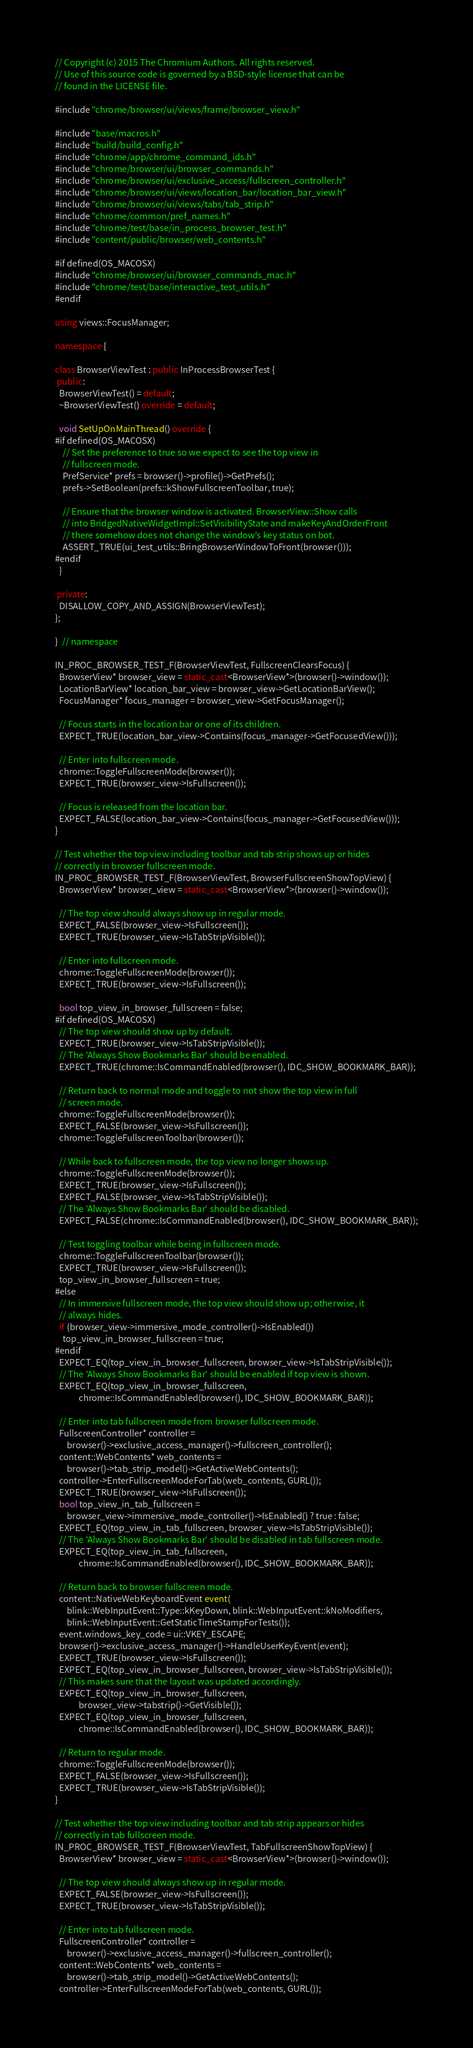Convert code to text. <code><loc_0><loc_0><loc_500><loc_500><_C++_>// Copyright (c) 2015 The Chromium Authors. All rights reserved.
// Use of this source code is governed by a BSD-style license that can be
// found in the LICENSE file.

#include "chrome/browser/ui/views/frame/browser_view.h"

#include "base/macros.h"
#include "build/build_config.h"
#include "chrome/app/chrome_command_ids.h"
#include "chrome/browser/ui/browser_commands.h"
#include "chrome/browser/ui/exclusive_access/fullscreen_controller.h"
#include "chrome/browser/ui/views/location_bar/location_bar_view.h"
#include "chrome/browser/ui/views/tabs/tab_strip.h"
#include "chrome/common/pref_names.h"
#include "chrome/test/base/in_process_browser_test.h"
#include "content/public/browser/web_contents.h"

#if defined(OS_MACOSX)
#include "chrome/browser/ui/browser_commands_mac.h"
#include "chrome/test/base/interactive_test_utils.h"
#endif

using views::FocusManager;

namespace {

class BrowserViewTest : public InProcessBrowserTest {
 public:
  BrowserViewTest() = default;
  ~BrowserViewTest() override = default;

  void SetUpOnMainThread() override {
#if defined(OS_MACOSX)
    // Set the preference to true so we expect to see the top view in
    // fullscreen mode.
    PrefService* prefs = browser()->profile()->GetPrefs();
    prefs->SetBoolean(prefs::kShowFullscreenToolbar, true);

    // Ensure that the browser window is activated. BrowserView::Show calls
    // into BridgedNativeWidgetImpl::SetVisibilityState and makeKeyAndOrderFront
    // there somehow does not change the window's key status on bot.
    ASSERT_TRUE(ui_test_utils::BringBrowserWindowToFront(browser()));
#endif
  }

 private:
  DISALLOW_COPY_AND_ASSIGN(BrowserViewTest);
};

}  // namespace

IN_PROC_BROWSER_TEST_F(BrowserViewTest, FullscreenClearsFocus) {
  BrowserView* browser_view = static_cast<BrowserView*>(browser()->window());
  LocationBarView* location_bar_view = browser_view->GetLocationBarView();
  FocusManager* focus_manager = browser_view->GetFocusManager();

  // Focus starts in the location bar or one of its children.
  EXPECT_TRUE(location_bar_view->Contains(focus_manager->GetFocusedView()));

  // Enter into fullscreen mode.
  chrome::ToggleFullscreenMode(browser());
  EXPECT_TRUE(browser_view->IsFullscreen());

  // Focus is released from the location bar.
  EXPECT_FALSE(location_bar_view->Contains(focus_manager->GetFocusedView()));
}

// Test whether the top view including toolbar and tab strip shows up or hides
// correctly in browser fullscreen mode.
IN_PROC_BROWSER_TEST_F(BrowserViewTest, BrowserFullscreenShowTopView) {
  BrowserView* browser_view = static_cast<BrowserView*>(browser()->window());

  // The top view should always show up in regular mode.
  EXPECT_FALSE(browser_view->IsFullscreen());
  EXPECT_TRUE(browser_view->IsTabStripVisible());

  // Enter into fullscreen mode.
  chrome::ToggleFullscreenMode(browser());
  EXPECT_TRUE(browser_view->IsFullscreen());

  bool top_view_in_browser_fullscreen = false;
#if defined(OS_MACOSX)
  // The top view should show up by default.
  EXPECT_TRUE(browser_view->IsTabStripVisible());
  // The 'Always Show Bookmarks Bar' should be enabled.
  EXPECT_TRUE(chrome::IsCommandEnabled(browser(), IDC_SHOW_BOOKMARK_BAR));

  // Return back to normal mode and toggle to not show the top view in full
  // screen mode.
  chrome::ToggleFullscreenMode(browser());
  EXPECT_FALSE(browser_view->IsFullscreen());
  chrome::ToggleFullscreenToolbar(browser());

  // While back to fullscreen mode, the top view no longer shows up.
  chrome::ToggleFullscreenMode(browser());
  EXPECT_TRUE(browser_view->IsFullscreen());
  EXPECT_FALSE(browser_view->IsTabStripVisible());
  // The 'Always Show Bookmarks Bar' should be disabled.
  EXPECT_FALSE(chrome::IsCommandEnabled(browser(), IDC_SHOW_BOOKMARK_BAR));

  // Test toggling toolbar while being in fullscreen mode.
  chrome::ToggleFullscreenToolbar(browser());
  EXPECT_TRUE(browser_view->IsFullscreen());
  top_view_in_browser_fullscreen = true;
#else
  // In immersive fullscreen mode, the top view should show up; otherwise, it
  // always hides.
  if (browser_view->immersive_mode_controller()->IsEnabled())
    top_view_in_browser_fullscreen = true;
#endif
  EXPECT_EQ(top_view_in_browser_fullscreen, browser_view->IsTabStripVisible());
  // The 'Always Show Bookmarks Bar' should be enabled if top view is shown.
  EXPECT_EQ(top_view_in_browser_fullscreen,
            chrome::IsCommandEnabled(browser(), IDC_SHOW_BOOKMARK_BAR));

  // Enter into tab fullscreen mode from browser fullscreen mode.
  FullscreenController* controller =
      browser()->exclusive_access_manager()->fullscreen_controller();
  content::WebContents* web_contents =
      browser()->tab_strip_model()->GetActiveWebContents();
  controller->EnterFullscreenModeForTab(web_contents, GURL());
  EXPECT_TRUE(browser_view->IsFullscreen());
  bool top_view_in_tab_fullscreen =
      browser_view->immersive_mode_controller()->IsEnabled() ? true : false;
  EXPECT_EQ(top_view_in_tab_fullscreen, browser_view->IsTabStripVisible());
  // The 'Always Show Bookmarks Bar' should be disabled in tab fullscreen mode.
  EXPECT_EQ(top_view_in_tab_fullscreen,
            chrome::IsCommandEnabled(browser(), IDC_SHOW_BOOKMARK_BAR));

  // Return back to browser fullscreen mode.
  content::NativeWebKeyboardEvent event(
      blink::WebInputEvent::Type::kKeyDown, blink::WebInputEvent::kNoModifiers,
      blink::WebInputEvent::GetStaticTimeStampForTests());
  event.windows_key_code = ui::VKEY_ESCAPE;
  browser()->exclusive_access_manager()->HandleUserKeyEvent(event);
  EXPECT_TRUE(browser_view->IsFullscreen());
  EXPECT_EQ(top_view_in_browser_fullscreen, browser_view->IsTabStripVisible());
  // This makes sure that the layout was updated accordingly.
  EXPECT_EQ(top_view_in_browser_fullscreen,
            browser_view->tabstrip()->GetVisible());
  EXPECT_EQ(top_view_in_browser_fullscreen,
            chrome::IsCommandEnabled(browser(), IDC_SHOW_BOOKMARK_BAR));

  // Return to regular mode.
  chrome::ToggleFullscreenMode(browser());
  EXPECT_FALSE(browser_view->IsFullscreen());
  EXPECT_TRUE(browser_view->IsTabStripVisible());
}

// Test whether the top view including toolbar and tab strip appears or hides
// correctly in tab fullscreen mode.
IN_PROC_BROWSER_TEST_F(BrowserViewTest, TabFullscreenShowTopView) {
  BrowserView* browser_view = static_cast<BrowserView*>(browser()->window());

  // The top view should always show up in regular mode.
  EXPECT_FALSE(browser_view->IsFullscreen());
  EXPECT_TRUE(browser_view->IsTabStripVisible());

  // Enter into tab fullscreen mode.
  FullscreenController* controller =
      browser()->exclusive_access_manager()->fullscreen_controller();
  content::WebContents* web_contents =
      browser()->tab_strip_model()->GetActiveWebContents();
  controller->EnterFullscreenModeForTab(web_contents, GURL());</code> 